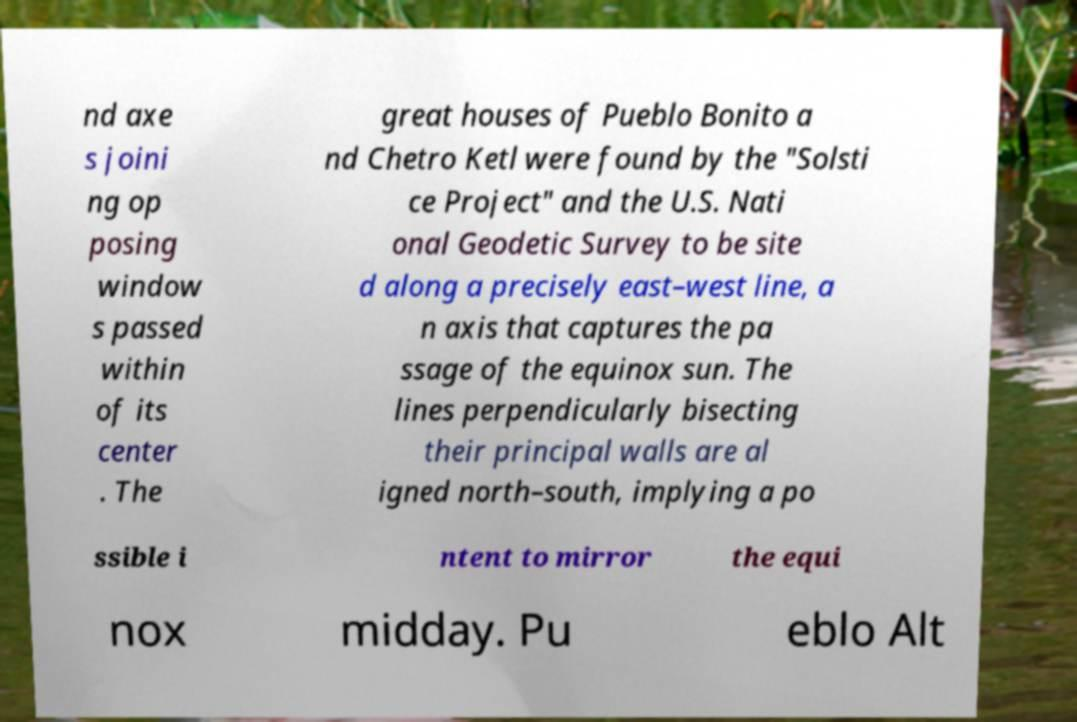Please identify and transcribe the text found in this image. nd axe s joini ng op posing window s passed within of its center . The great houses of Pueblo Bonito a nd Chetro Ketl were found by the "Solsti ce Project" and the U.S. Nati onal Geodetic Survey to be site d along a precisely east–west line, a n axis that captures the pa ssage of the equinox sun. The lines perpendicularly bisecting their principal walls are al igned north–south, implying a po ssible i ntent to mirror the equi nox midday. Pu eblo Alt 